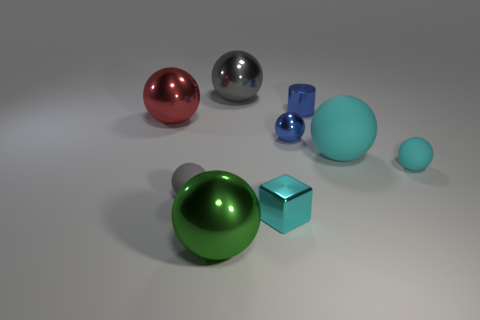There is a large matte object that is the same color as the shiny block; what is its shape?
Ensure brevity in your answer.  Sphere. There is a small ball left of the blue object that is in front of the metal sphere that is left of the green metallic object; what is it made of?
Provide a succinct answer. Rubber. Does the big gray thing left of the big cyan rubber ball have the same shape as the large cyan rubber thing?
Offer a terse response. Yes. There is a tiny cyan thing behind the tiny cyan metallic thing; what is its material?
Provide a short and direct response. Rubber. What number of shiny things are gray balls or cyan cubes?
Your response must be concise. 2. Is there a yellow matte cylinder that has the same size as the gray rubber ball?
Keep it short and to the point. No. Is the number of gray metallic balls that are in front of the green metal thing greater than the number of blue blocks?
Offer a very short reply. No. What number of small things are either gray metal balls or red cylinders?
Give a very brief answer. 0. How many other big matte objects are the same shape as the red thing?
Ensure brevity in your answer.  1. What material is the gray ball that is right of the metal sphere that is in front of the cyan block?
Your answer should be very brief. Metal. 